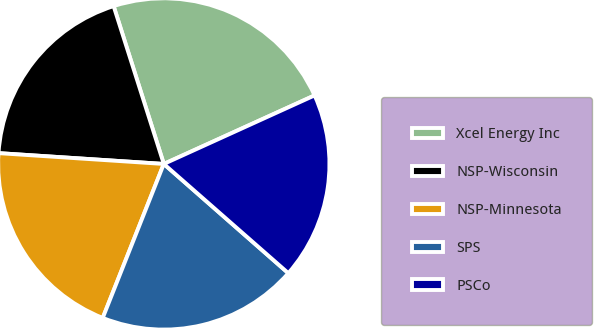Convert chart to OTSL. <chart><loc_0><loc_0><loc_500><loc_500><pie_chart><fcel>Xcel Energy Inc<fcel>NSP-Wisconsin<fcel>NSP-Minnesota<fcel>SPS<fcel>PSCo<nl><fcel>23.11%<fcel>19.06%<fcel>20.03%<fcel>19.55%<fcel>18.25%<nl></chart> 